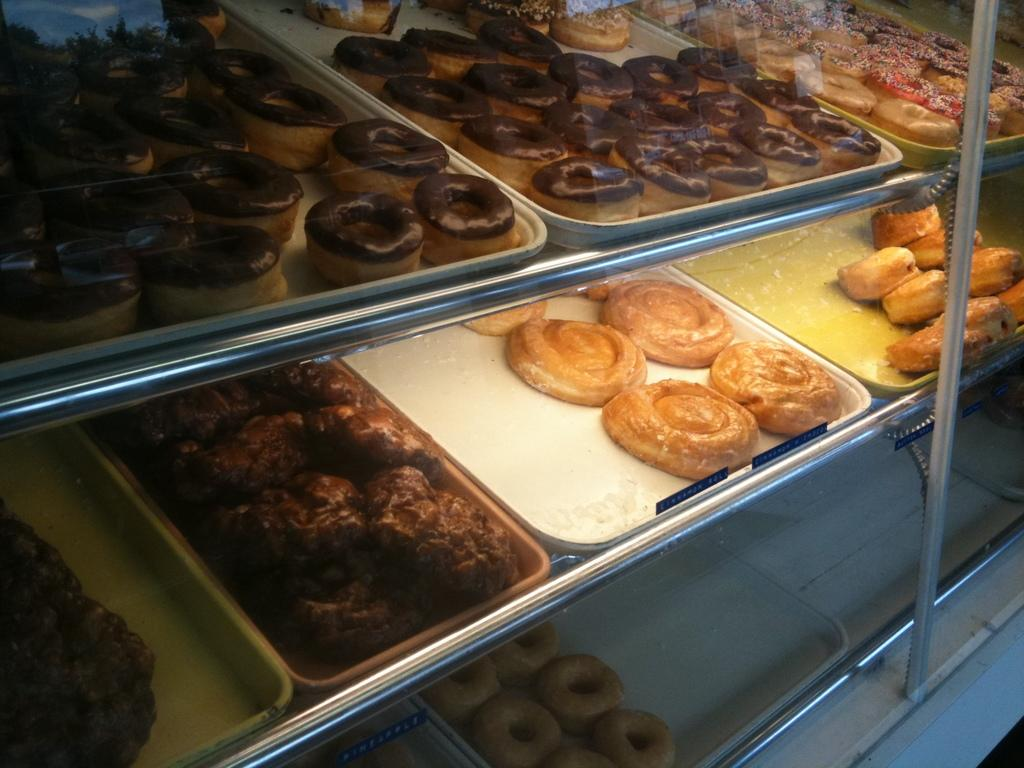What type of food items can be seen in the image? There is a group of donuts in the image. How are the food items arranged in the image? The food items are placed on trays in the image. Where are the trays located in the image? The trays are kept on racks in the image. What can be seen to the right side of the image? There is a pole visible to the right side of the image. What type of window can be seen in the image? There is no window present in the image; it features a group of donuts, food items on trays, and a pole. What kind of coach is visible in the image? There is no coach present in the image. 